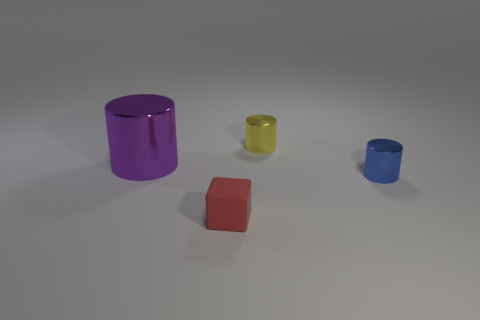Add 1 big blue balls. How many objects exist? 5 Subtract all cylinders. How many objects are left? 1 Subtract 0 brown cubes. How many objects are left? 4 Subtract all tiny blue metal objects. Subtract all purple cylinders. How many objects are left? 2 Add 2 red rubber objects. How many red rubber objects are left? 3 Add 1 gray metal balls. How many gray metal balls exist? 1 